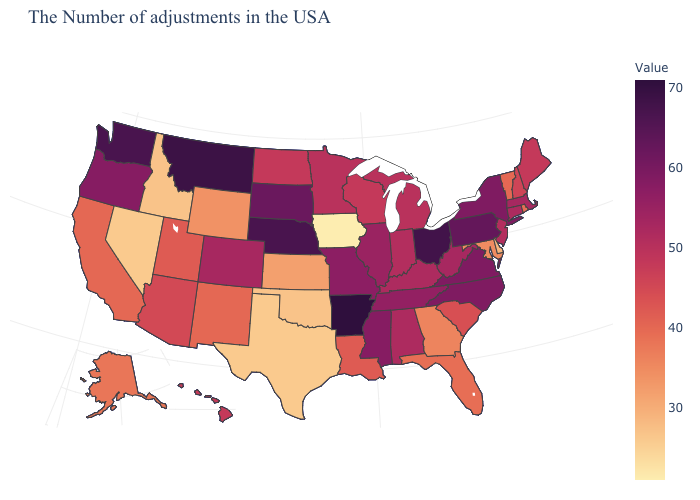Does Arkansas have the highest value in the USA?
Keep it brief. Yes. Does New Jersey have a higher value than Rhode Island?
Keep it brief. Yes. Among the states that border Rhode Island , which have the lowest value?
Answer briefly. Connecticut. Among the states that border Missouri , does Kansas have the lowest value?
Be succinct. No. Which states have the lowest value in the South?
Give a very brief answer. Texas. 